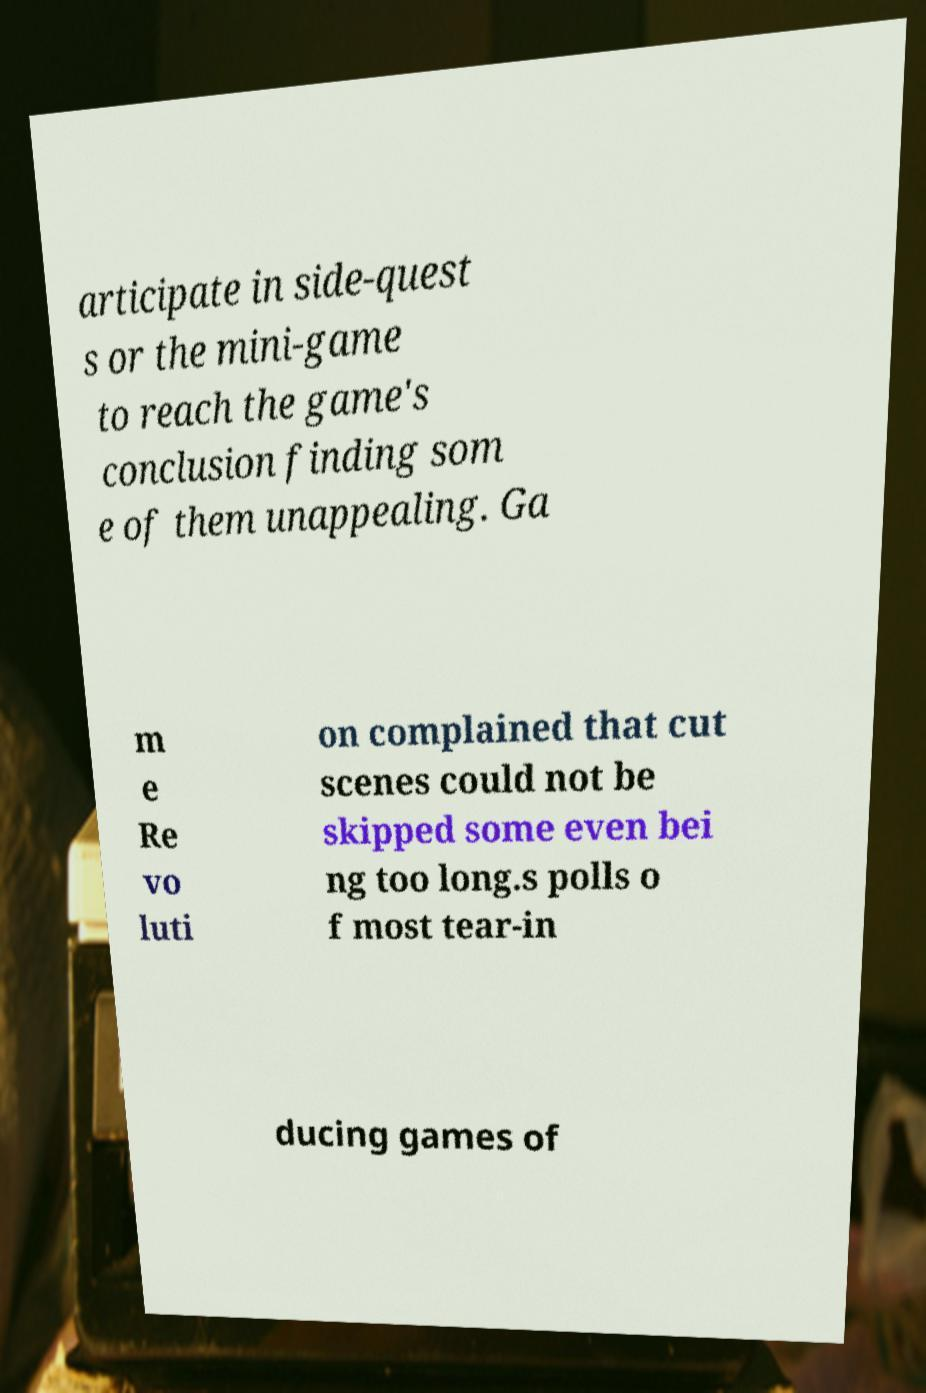For documentation purposes, I need the text within this image transcribed. Could you provide that? articipate in side-quest s or the mini-game to reach the game's conclusion finding som e of them unappealing. Ga m e Re vo luti on complained that cut scenes could not be skipped some even bei ng too long.s polls o f most tear-in ducing games of 